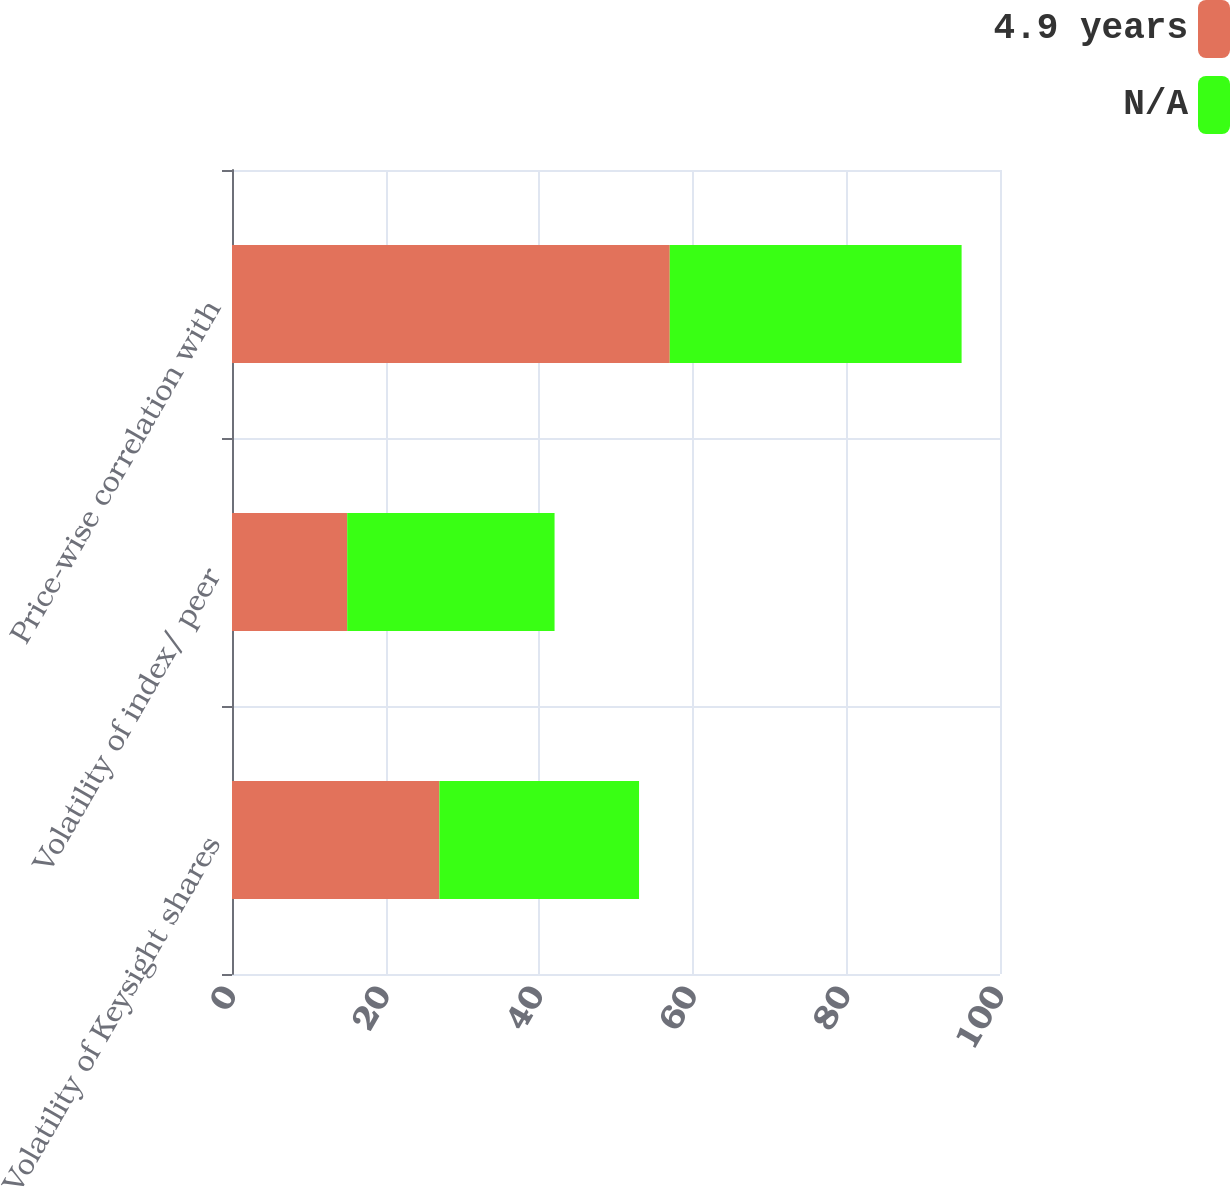Convert chart to OTSL. <chart><loc_0><loc_0><loc_500><loc_500><stacked_bar_chart><ecel><fcel>Volatility of Keysight shares<fcel>Volatility of index/ peer<fcel>Price-wise correlation with<nl><fcel>4.9 years<fcel>27<fcel>15<fcel>57<nl><fcel>nan<fcel>26<fcel>27<fcel>38<nl></chart> 